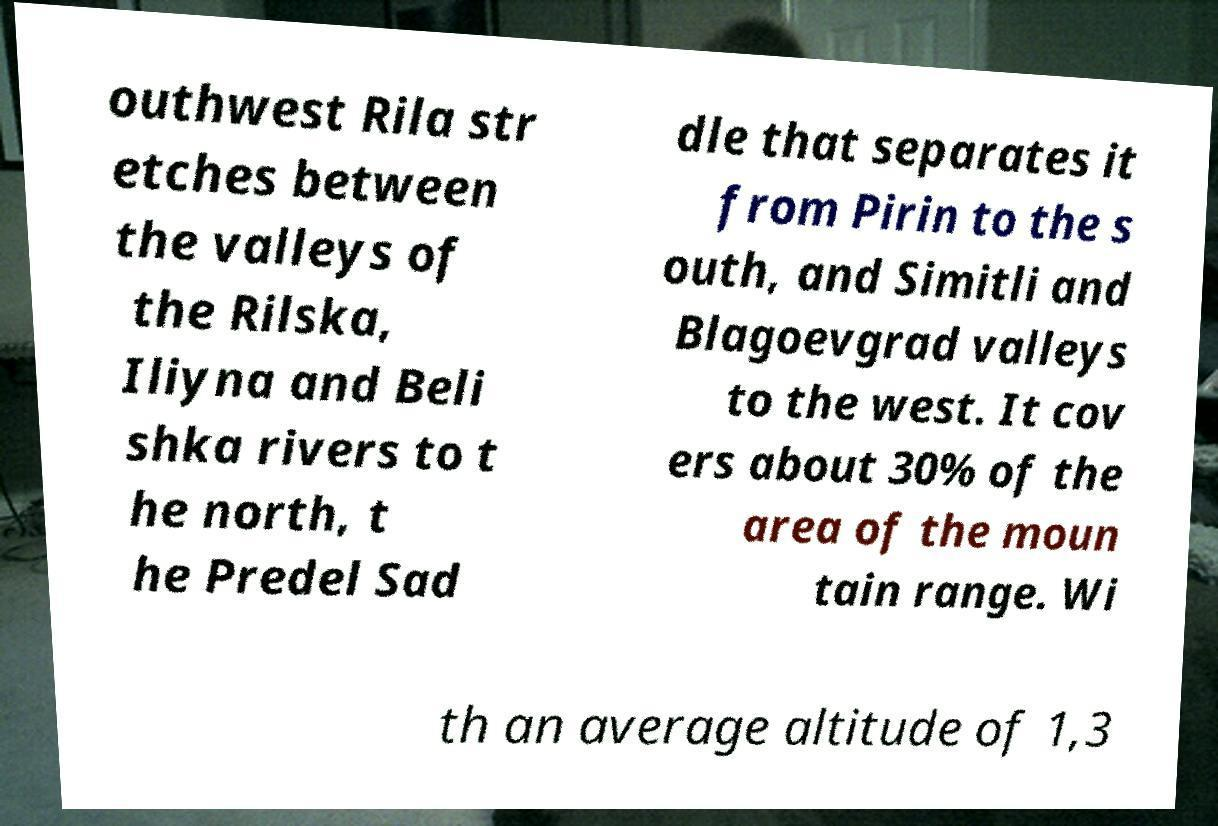Could you extract and type out the text from this image? outhwest Rila str etches between the valleys of the Rilska, Iliyna and Beli shka rivers to t he north, t he Predel Sad dle that separates it from Pirin to the s outh, and Simitli and Blagoevgrad valleys to the west. It cov ers about 30% of the area of the moun tain range. Wi th an average altitude of 1,3 